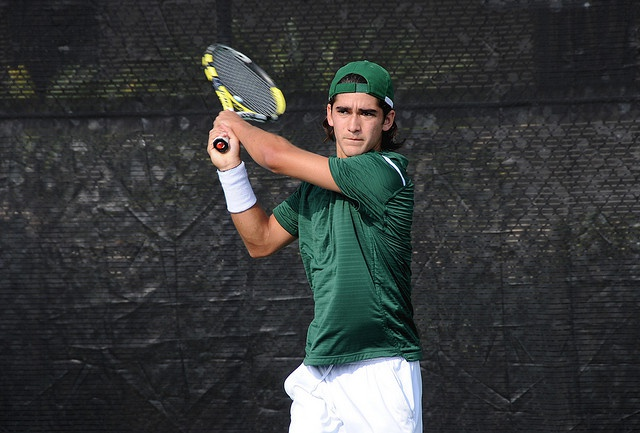Describe the objects in this image and their specific colors. I can see people in black, white, teal, and salmon tones and tennis racket in black, gray, darkgray, and khaki tones in this image. 